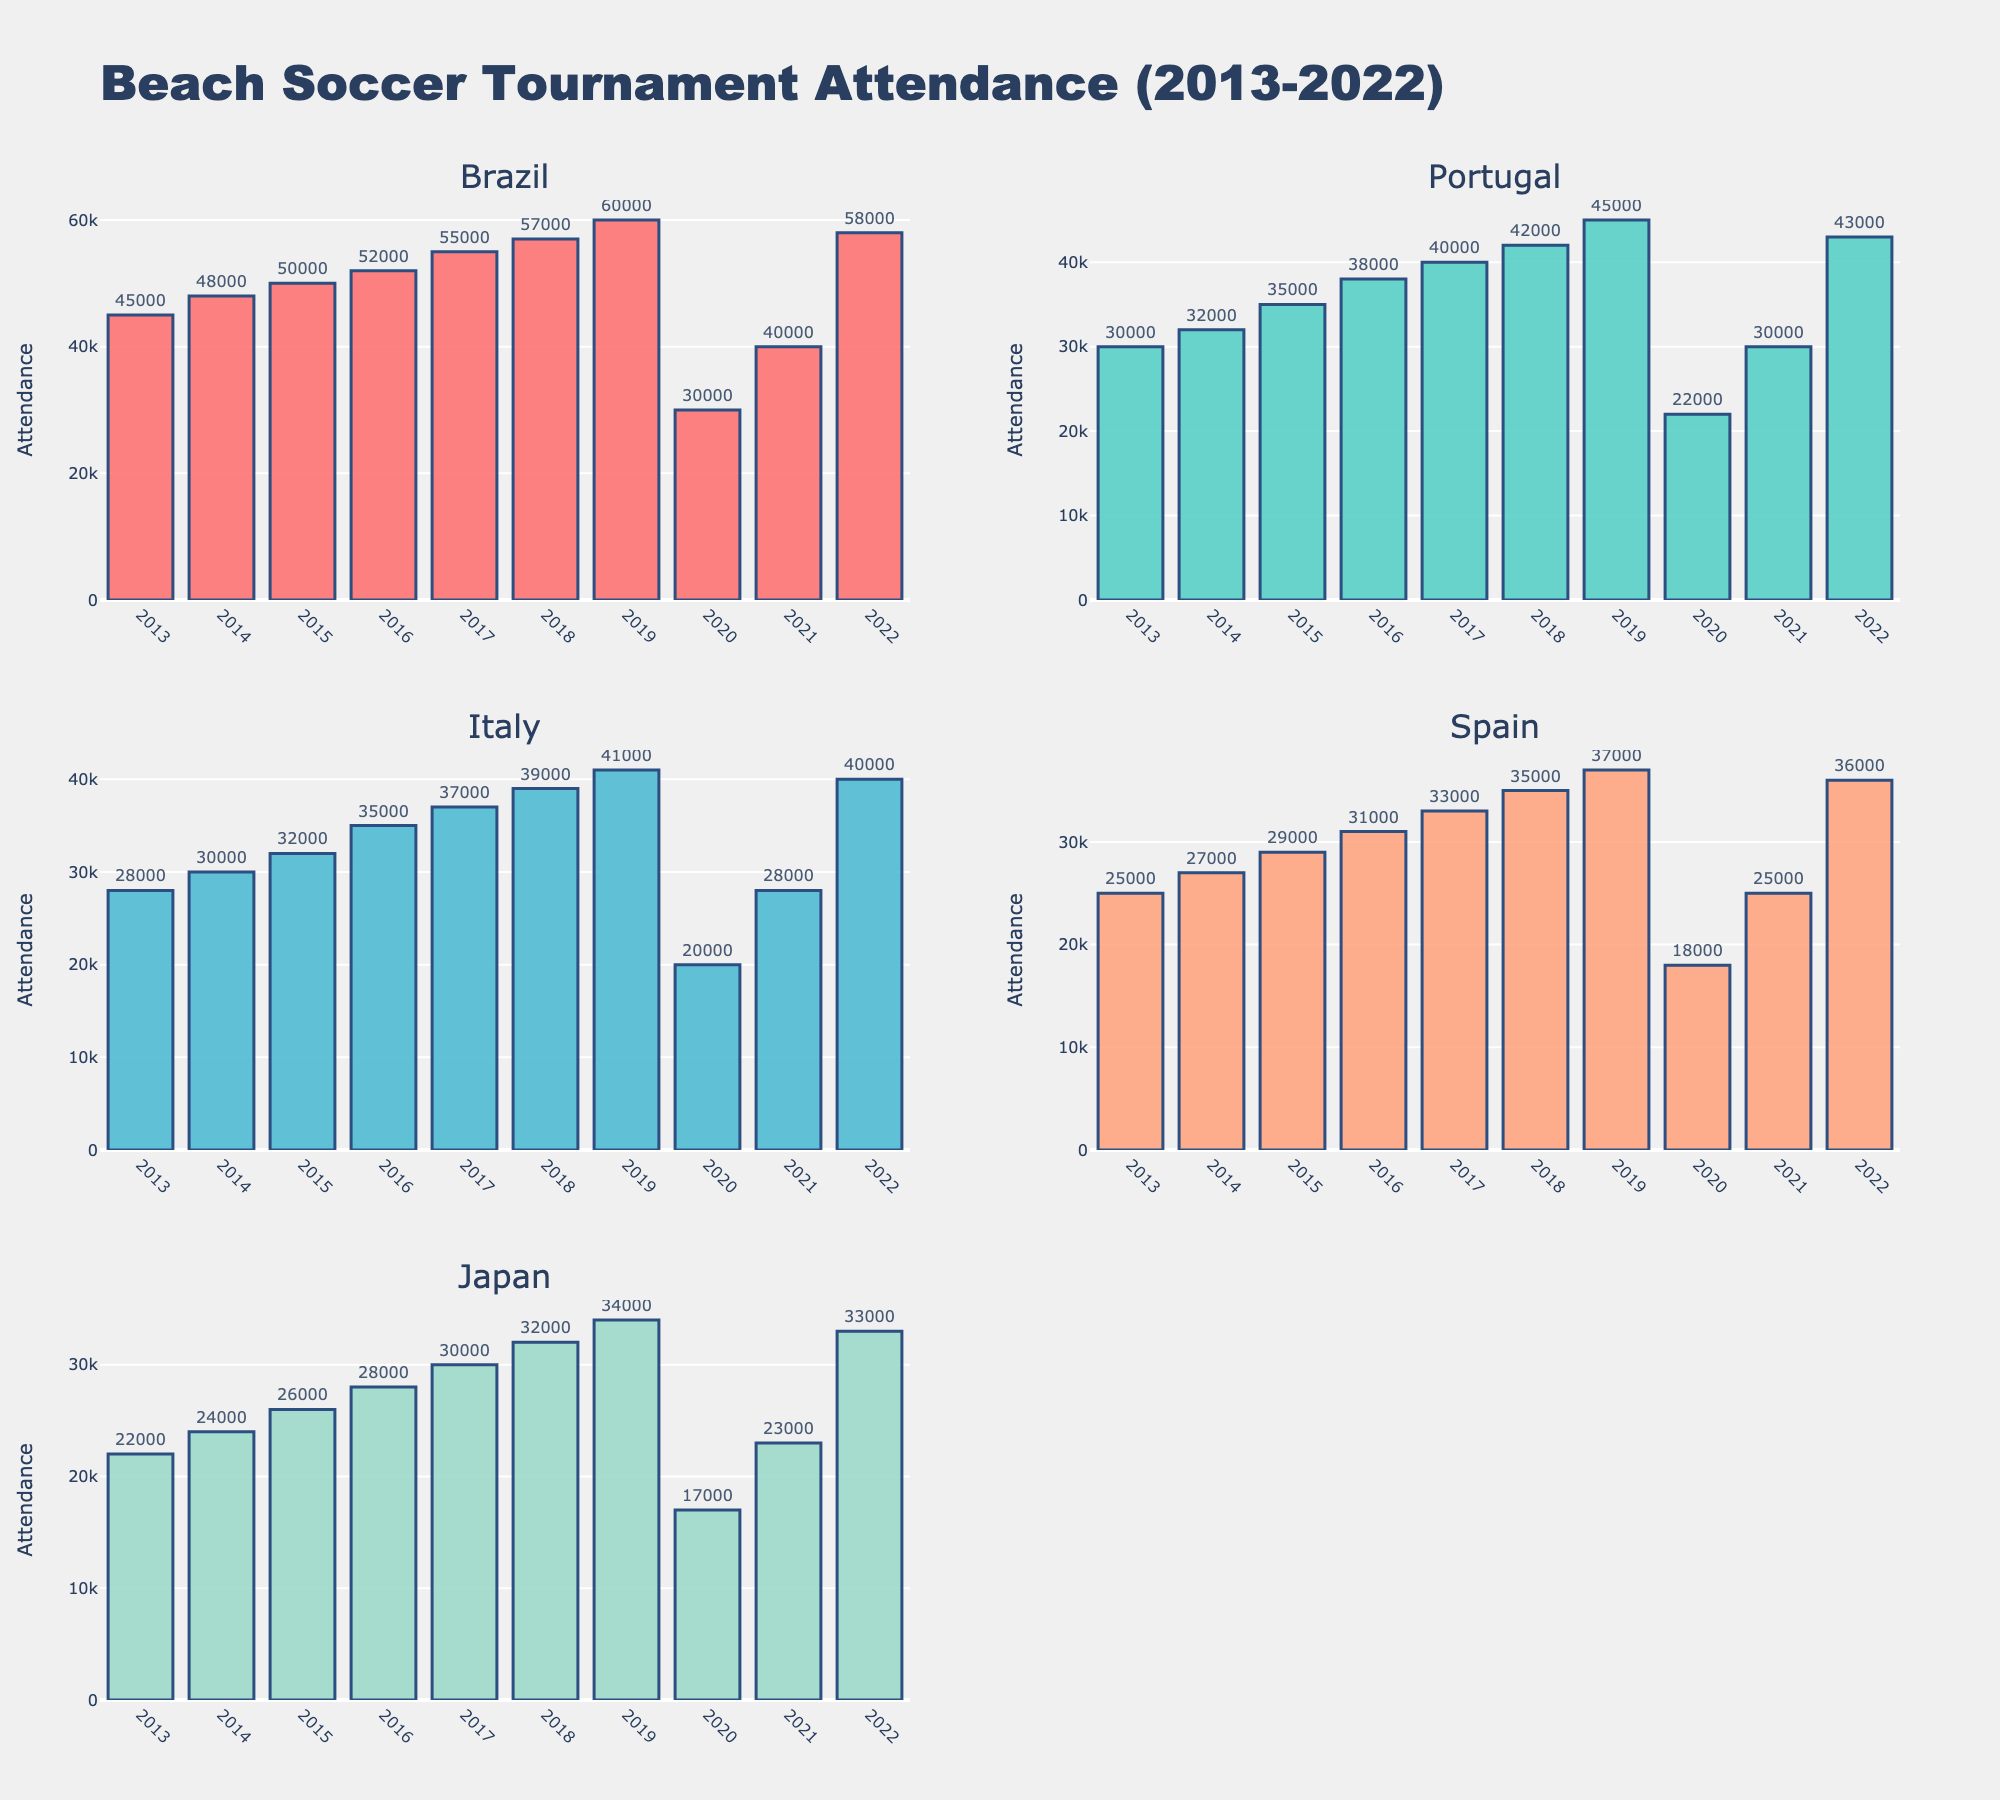What's the title of the figure? The title is found at the top of the figure.
Answer: Beach Soccer Tournament Attendance (2013-2022) How many countries are compared in the subplot? Count the number of subplot titles listed.
Answer: 5 Which country has the highest attendance in 2022? Look for the highest bar in the 2022 data across all subplots.
Answer: Brazil Which country had the least attendance in 2020? Look at the 2020 bar for each country and identify the smallest one.
Answer: Japan What color represents Italy in the subplots? Check the color of the bars in the subplot titled 'Italy'.
Answer: Light blue or '#45B7D1' What is the attendance range for Portugal between 2013 and 2022? Subtract the smallest attendance value from the largest value for Portugal. The smallest value is 22000 in 2020, and the largest value is 45000 in 2019. The difference is 45000 - 22000 = 23000.
Answer: 23000 How did the attendance in Brazil change from 2019 to 2020? Subtract the attendance value in 2020 from 2019 for Brazil. The attendance in 2019 is 60000, and in 2020 it is 30000. The difference is 30000 - 60000 = -30000.
Answer: Decreased by 30000 Which country saw the largest increase in attendance from 2021 to 2022? Calculate the difference in attendance from 2021 to 2022 for each country and identify the maximum increase.
- Brazil: 58000 - 40000 = 18000
- Portugal: 43000 - 30000 = 13000
- Italy: 40000 - 28000 = 12000
- Spain: 36000 - 25000 = 11000
- Japan: 33000 - 23000 = 10000
The largest increase is for Brazil.
Answer: Brazil In which year did Spain have the highest attendance, and what was the value? Identify the tallest bar in Spain's subplot and note the year and value. The highest bar for Spain is in 2022 with 36000.
Answer: 2022, 36000 What is the overall trend of attendance in Japan from 2013 to 2022? Observe all the bars for Japan to describe the trend. The attendance shows a general increasing trend from 2013 to 2019, a dip in 2020, followed by recovery in 2021 and 2022.
Answer: Increasing trend with a dip in 2020 